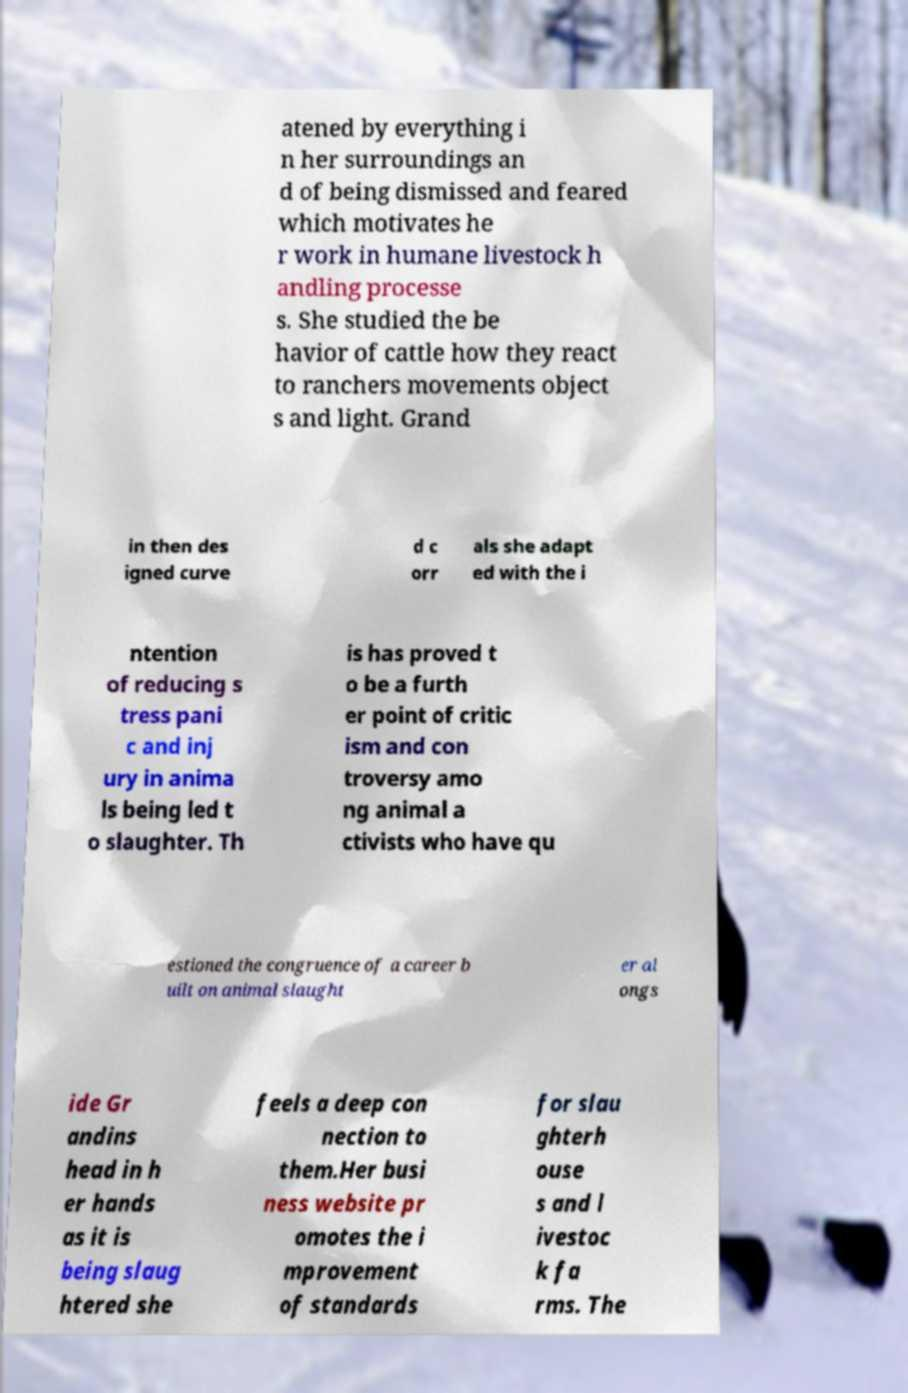For documentation purposes, I need the text within this image transcribed. Could you provide that? atened by everything i n her surroundings an d of being dismissed and feared which motivates he r work in humane livestock h andling processe s. She studied the be havior of cattle how they react to ranchers movements object s and light. Grand in then des igned curve d c orr als she adapt ed with the i ntention of reducing s tress pani c and inj ury in anima ls being led t o slaughter. Th is has proved t o be a furth er point of critic ism and con troversy amo ng animal a ctivists who have qu estioned the congruence of a career b uilt on animal slaught er al ongs ide Gr andins head in h er hands as it is being slaug htered she feels a deep con nection to them.Her busi ness website pr omotes the i mprovement of standards for slau ghterh ouse s and l ivestoc k fa rms. The 